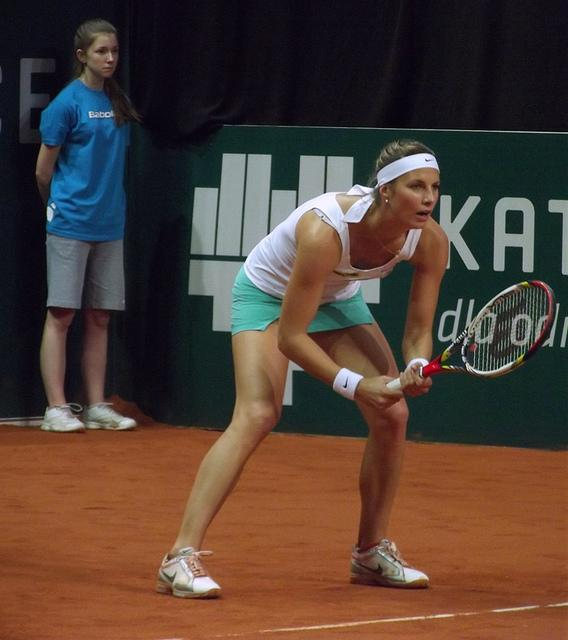What is she ready to do?

Choices:
A) swing
B) sit
C) swim
D) eat swing 